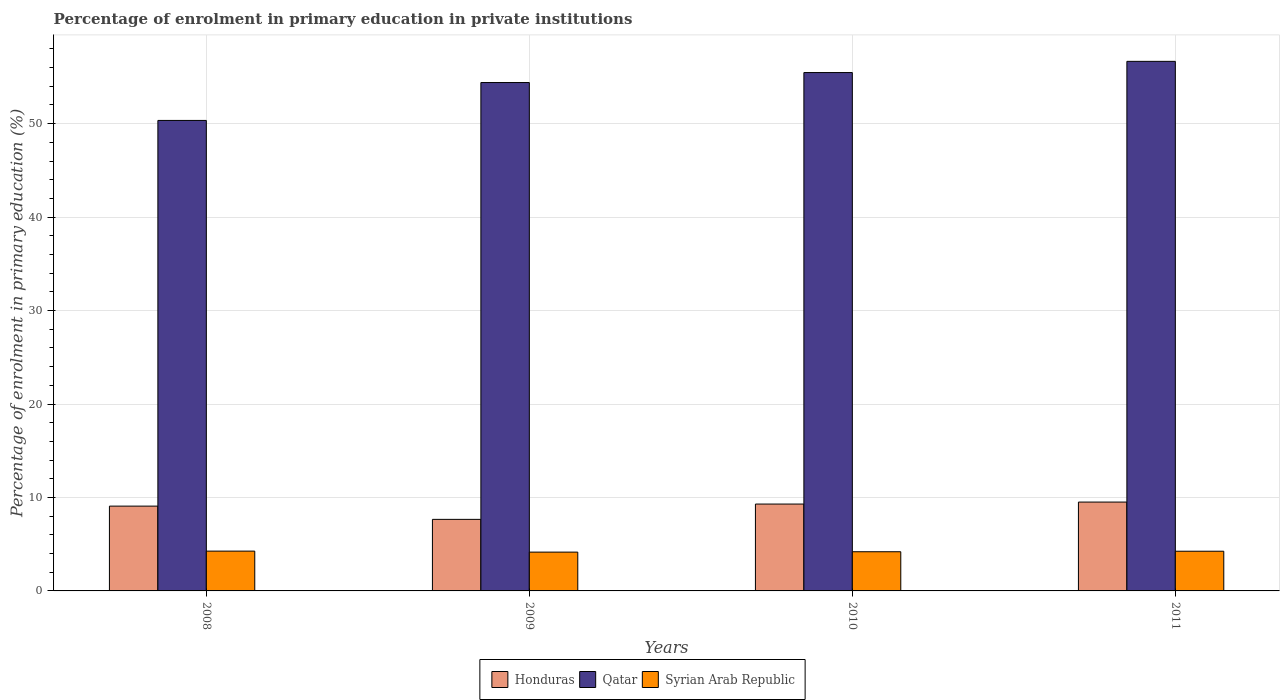How many different coloured bars are there?
Provide a succinct answer. 3. How many groups of bars are there?
Provide a succinct answer. 4. Are the number of bars per tick equal to the number of legend labels?
Offer a terse response. Yes. Are the number of bars on each tick of the X-axis equal?
Provide a succinct answer. Yes. How many bars are there on the 1st tick from the right?
Give a very brief answer. 3. What is the label of the 3rd group of bars from the left?
Offer a terse response. 2010. What is the percentage of enrolment in primary education in Syrian Arab Republic in 2008?
Keep it short and to the point. 4.26. Across all years, what is the maximum percentage of enrolment in primary education in Honduras?
Give a very brief answer. 9.51. Across all years, what is the minimum percentage of enrolment in primary education in Syrian Arab Republic?
Make the answer very short. 4.15. In which year was the percentage of enrolment in primary education in Qatar minimum?
Offer a very short reply. 2008. What is the total percentage of enrolment in primary education in Syrian Arab Republic in the graph?
Your answer should be compact. 16.85. What is the difference between the percentage of enrolment in primary education in Syrian Arab Republic in 2009 and that in 2010?
Your response must be concise. -0.04. What is the difference between the percentage of enrolment in primary education in Qatar in 2010 and the percentage of enrolment in primary education in Honduras in 2009?
Offer a terse response. 47.81. What is the average percentage of enrolment in primary education in Syrian Arab Republic per year?
Make the answer very short. 4.21. In the year 2008, what is the difference between the percentage of enrolment in primary education in Qatar and percentage of enrolment in primary education in Syrian Arab Republic?
Offer a terse response. 46.08. What is the ratio of the percentage of enrolment in primary education in Syrian Arab Republic in 2009 to that in 2010?
Your answer should be compact. 0.99. Is the percentage of enrolment in primary education in Qatar in 2008 less than that in 2010?
Give a very brief answer. Yes. What is the difference between the highest and the second highest percentage of enrolment in primary education in Qatar?
Keep it short and to the point. 1.2. What is the difference between the highest and the lowest percentage of enrolment in primary education in Honduras?
Your answer should be very brief. 1.85. Is the sum of the percentage of enrolment in primary education in Honduras in 2008 and 2010 greater than the maximum percentage of enrolment in primary education in Qatar across all years?
Ensure brevity in your answer.  No. What does the 3rd bar from the left in 2011 represents?
Offer a terse response. Syrian Arab Republic. What does the 1st bar from the right in 2008 represents?
Give a very brief answer. Syrian Arab Republic. Is it the case that in every year, the sum of the percentage of enrolment in primary education in Qatar and percentage of enrolment in primary education in Syrian Arab Republic is greater than the percentage of enrolment in primary education in Honduras?
Make the answer very short. Yes. Are all the bars in the graph horizontal?
Offer a terse response. No. How many years are there in the graph?
Your response must be concise. 4. How many legend labels are there?
Provide a short and direct response. 3. What is the title of the graph?
Give a very brief answer. Percentage of enrolment in primary education in private institutions. Does "Togo" appear as one of the legend labels in the graph?
Your answer should be compact. No. What is the label or title of the X-axis?
Offer a very short reply. Years. What is the label or title of the Y-axis?
Ensure brevity in your answer.  Percentage of enrolment in primary education (%). What is the Percentage of enrolment in primary education (%) in Honduras in 2008?
Your answer should be very brief. 9.07. What is the Percentage of enrolment in primary education (%) of Qatar in 2008?
Provide a short and direct response. 50.34. What is the Percentage of enrolment in primary education (%) of Syrian Arab Republic in 2008?
Provide a succinct answer. 4.26. What is the Percentage of enrolment in primary education (%) of Honduras in 2009?
Give a very brief answer. 7.66. What is the Percentage of enrolment in primary education (%) in Qatar in 2009?
Your answer should be very brief. 54.4. What is the Percentage of enrolment in primary education (%) in Syrian Arab Republic in 2009?
Offer a terse response. 4.15. What is the Percentage of enrolment in primary education (%) of Honduras in 2010?
Your answer should be compact. 9.3. What is the Percentage of enrolment in primary education (%) in Qatar in 2010?
Your answer should be compact. 55.47. What is the Percentage of enrolment in primary education (%) in Syrian Arab Republic in 2010?
Make the answer very short. 4.19. What is the Percentage of enrolment in primary education (%) in Honduras in 2011?
Give a very brief answer. 9.51. What is the Percentage of enrolment in primary education (%) of Qatar in 2011?
Offer a terse response. 56.67. What is the Percentage of enrolment in primary education (%) in Syrian Arab Republic in 2011?
Offer a terse response. 4.25. Across all years, what is the maximum Percentage of enrolment in primary education (%) of Honduras?
Offer a very short reply. 9.51. Across all years, what is the maximum Percentage of enrolment in primary education (%) in Qatar?
Provide a succinct answer. 56.67. Across all years, what is the maximum Percentage of enrolment in primary education (%) of Syrian Arab Republic?
Provide a succinct answer. 4.26. Across all years, what is the minimum Percentage of enrolment in primary education (%) in Honduras?
Provide a short and direct response. 7.66. Across all years, what is the minimum Percentage of enrolment in primary education (%) in Qatar?
Make the answer very short. 50.34. Across all years, what is the minimum Percentage of enrolment in primary education (%) in Syrian Arab Republic?
Ensure brevity in your answer.  4.15. What is the total Percentage of enrolment in primary education (%) in Honduras in the graph?
Provide a short and direct response. 35.53. What is the total Percentage of enrolment in primary education (%) of Qatar in the graph?
Offer a very short reply. 216.88. What is the total Percentage of enrolment in primary education (%) in Syrian Arab Republic in the graph?
Your answer should be compact. 16.85. What is the difference between the Percentage of enrolment in primary education (%) in Honduras in 2008 and that in 2009?
Offer a very short reply. 1.42. What is the difference between the Percentage of enrolment in primary education (%) in Qatar in 2008 and that in 2009?
Give a very brief answer. -4.06. What is the difference between the Percentage of enrolment in primary education (%) in Syrian Arab Republic in 2008 and that in 2009?
Make the answer very short. 0.11. What is the difference between the Percentage of enrolment in primary education (%) in Honduras in 2008 and that in 2010?
Your answer should be very brief. -0.22. What is the difference between the Percentage of enrolment in primary education (%) of Qatar in 2008 and that in 2010?
Your answer should be very brief. -5.12. What is the difference between the Percentage of enrolment in primary education (%) of Syrian Arab Republic in 2008 and that in 2010?
Offer a terse response. 0.07. What is the difference between the Percentage of enrolment in primary education (%) of Honduras in 2008 and that in 2011?
Provide a short and direct response. -0.43. What is the difference between the Percentage of enrolment in primary education (%) in Qatar in 2008 and that in 2011?
Provide a short and direct response. -6.32. What is the difference between the Percentage of enrolment in primary education (%) in Syrian Arab Republic in 2008 and that in 2011?
Provide a succinct answer. 0.01. What is the difference between the Percentage of enrolment in primary education (%) in Honduras in 2009 and that in 2010?
Your response must be concise. -1.64. What is the difference between the Percentage of enrolment in primary education (%) in Qatar in 2009 and that in 2010?
Your answer should be compact. -1.07. What is the difference between the Percentage of enrolment in primary education (%) in Syrian Arab Republic in 2009 and that in 2010?
Keep it short and to the point. -0.04. What is the difference between the Percentage of enrolment in primary education (%) of Honduras in 2009 and that in 2011?
Ensure brevity in your answer.  -1.85. What is the difference between the Percentage of enrolment in primary education (%) in Qatar in 2009 and that in 2011?
Your answer should be compact. -2.27. What is the difference between the Percentage of enrolment in primary education (%) of Syrian Arab Republic in 2009 and that in 2011?
Your response must be concise. -0.1. What is the difference between the Percentage of enrolment in primary education (%) in Honduras in 2010 and that in 2011?
Keep it short and to the point. -0.21. What is the difference between the Percentage of enrolment in primary education (%) in Qatar in 2010 and that in 2011?
Ensure brevity in your answer.  -1.2. What is the difference between the Percentage of enrolment in primary education (%) of Syrian Arab Republic in 2010 and that in 2011?
Offer a very short reply. -0.06. What is the difference between the Percentage of enrolment in primary education (%) in Honduras in 2008 and the Percentage of enrolment in primary education (%) in Qatar in 2009?
Give a very brief answer. -45.33. What is the difference between the Percentage of enrolment in primary education (%) of Honduras in 2008 and the Percentage of enrolment in primary education (%) of Syrian Arab Republic in 2009?
Your response must be concise. 4.92. What is the difference between the Percentage of enrolment in primary education (%) of Qatar in 2008 and the Percentage of enrolment in primary education (%) of Syrian Arab Republic in 2009?
Ensure brevity in your answer.  46.19. What is the difference between the Percentage of enrolment in primary education (%) of Honduras in 2008 and the Percentage of enrolment in primary education (%) of Qatar in 2010?
Your answer should be very brief. -46.39. What is the difference between the Percentage of enrolment in primary education (%) in Honduras in 2008 and the Percentage of enrolment in primary education (%) in Syrian Arab Republic in 2010?
Give a very brief answer. 4.88. What is the difference between the Percentage of enrolment in primary education (%) of Qatar in 2008 and the Percentage of enrolment in primary education (%) of Syrian Arab Republic in 2010?
Provide a short and direct response. 46.15. What is the difference between the Percentage of enrolment in primary education (%) in Honduras in 2008 and the Percentage of enrolment in primary education (%) in Qatar in 2011?
Your response must be concise. -47.59. What is the difference between the Percentage of enrolment in primary education (%) of Honduras in 2008 and the Percentage of enrolment in primary education (%) of Syrian Arab Republic in 2011?
Make the answer very short. 4.83. What is the difference between the Percentage of enrolment in primary education (%) of Qatar in 2008 and the Percentage of enrolment in primary education (%) of Syrian Arab Republic in 2011?
Your response must be concise. 46.1. What is the difference between the Percentage of enrolment in primary education (%) in Honduras in 2009 and the Percentage of enrolment in primary education (%) in Qatar in 2010?
Keep it short and to the point. -47.81. What is the difference between the Percentage of enrolment in primary education (%) of Honduras in 2009 and the Percentage of enrolment in primary education (%) of Syrian Arab Republic in 2010?
Keep it short and to the point. 3.47. What is the difference between the Percentage of enrolment in primary education (%) of Qatar in 2009 and the Percentage of enrolment in primary education (%) of Syrian Arab Republic in 2010?
Make the answer very short. 50.21. What is the difference between the Percentage of enrolment in primary education (%) in Honduras in 2009 and the Percentage of enrolment in primary education (%) in Qatar in 2011?
Ensure brevity in your answer.  -49.01. What is the difference between the Percentage of enrolment in primary education (%) in Honduras in 2009 and the Percentage of enrolment in primary education (%) in Syrian Arab Republic in 2011?
Offer a terse response. 3.41. What is the difference between the Percentage of enrolment in primary education (%) in Qatar in 2009 and the Percentage of enrolment in primary education (%) in Syrian Arab Republic in 2011?
Your answer should be compact. 50.15. What is the difference between the Percentage of enrolment in primary education (%) in Honduras in 2010 and the Percentage of enrolment in primary education (%) in Qatar in 2011?
Provide a succinct answer. -47.37. What is the difference between the Percentage of enrolment in primary education (%) of Honduras in 2010 and the Percentage of enrolment in primary education (%) of Syrian Arab Republic in 2011?
Offer a very short reply. 5.05. What is the difference between the Percentage of enrolment in primary education (%) of Qatar in 2010 and the Percentage of enrolment in primary education (%) of Syrian Arab Republic in 2011?
Provide a short and direct response. 51.22. What is the average Percentage of enrolment in primary education (%) in Honduras per year?
Make the answer very short. 8.88. What is the average Percentage of enrolment in primary education (%) of Qatar per year?
Provide a succinct answer. 54.22. What is the average Percentage of enrolment in primary education (%) of Syrian Arab Republic per year?
Your response must be concise. 4.21. In the year 2008, what is the difference between the Percentage of enrolment in primary education (%) of Honduras and Percentage of enrolment in primary education (%) of Qatar?
Your response must be concise. -41.27. In the year 2008, what is the difference between the Percentage of enrolment in primary education (%) in Honduras and Percentage of enrolment in primary education (%) in Syrian Arab Republic?
Make the answer very short. 4.81. In the year 2008, what is the difference between the Percentage of enrolment in primary education (%) in Qatar and Percentage of enrolment in primary education (%) in Syrian Arab Republic?
Your response must be concise. 46.08. In the year 2009, what is the difference between the Percentage of enrolment in primary education (%) in Honduras and Percentage of enrolment in primary education (%) in Qatar?
Offer a very short reply. -46.74. In the year 2009, what is the difference between the Percentage of enrolment in primary education (%) in Honduras and Percentage of enrolment in primary education (%) in Syrian Arab Republic?
Give a very brief answer. 3.5. In the year 2009, what is the difference between the Percentage of enrolment in primary education (%) in Qatar and Percentage of enrolment in primary education (%) in Syrian Arab Republic?
Your answer should be very brief. 50.25. In the year 2010, what is the difference between the Percentage of enrolment in primary education (%) of Honduras and Percentage of enrolment in primary education (%) of Qatar?
Make the answer very short. -46.17. In the year 2010, what is the difference between the Percentage of enrolment in primary education (%) of Honduras and Percentage of enrolment in primary education (%) of Syrian Arab Republic?
Your response must be concise. 5.1. In the year 2010, what is the difference between the Percentage of enrolment in primary education (%) of Qatar and Percentage of enrolment in primary education (%) of Syrian Arab Republic?
Provide a succinct answer. 51.28. In the year 2011, what is the difference between the Percentage of enrolment in primary education (%) of Honduras and Percentage of enrolment in primary education (%) of Qatar?
Give a very brief answer. -47.16. In the year 2011, what is the difference between the Percentage of enrolment in primary education (%) of Honduras and Percentage of enrolment in primary education (%) of Syrian Arab Republic?
Offer a very short reply. 5.26. In the year 2011, what is the difference between the Percentage of enrolment in primary education (%) in Qatar and Percentage of enrolment in primary education (%) in Syrian Arab Republic?
Offer a terse response. 52.42. What is the ratio of the Percentage of enrolment in primary education (%) of Honduras in 2008 to that in 2009?
Offer a very short reply. 1.19. What is the ratio of the Percentage of enrolment in primary education (%) of Qatar in 2008 to that in 2009?
Your answer should be compact. 0.93. What is the ratio of the Percentage of enrolment in primary education (%) in Syrian Arab Republic in 2008 to that in 2009?
Keep it short and to the point. 1.03. What is the ratio of the Percentage of enrolment in primary education (%) in Honduras in 2008 to that in 2010?
Make the answer very short. 0.98. What is the ratio of the Percentage of enrolment in primary education (%) in Qatar in 2008 to that in 2010?
Make the answer very short. 0.91. What is the ratio of the Percentage of enrolment in primary education (%) in Syrian Arab Republic in 2008 to that in 2010?
Keep it short and to the point. 1.02. What is the ratio of the Percentage of enrolment in primary education (%) of Honduras in 2008 to that in 2011?
Offer a very short reply. 0.95. What is the ratio of the Percentage of enrolment in primary education (%) of Qatar in 2008 to that in 2011?
Your answer should be very brief. 0.89. What is the ratio of the Percentage of enrolment in primary education (%) in Syrian Arab Republic in 2008 to that in 2011?
Give a very brief answer. 1. What is the ratio of the Percentage of enrolment in primary education (%) in Honduras in 2009 to that in 2010?
Offer a terse response. 0.82. What is the ratio of the Percentage of enrolment in primary education (%) in Qatar in 2009 to that in 2010?
Your response must be concise. 0.98. What is the ratio of the Percentage of enrolment in primary education (%) in Honduras in 2009 to that in 2011?
Give a very brief answer. 0.81. What is the ratio of the Percentage of enrolment in primary education (%) of Syrian Arab Republic in 2009 to that in 2011?
Your answer should be very brief. 0.98. What is the ratio of the Percentage of enrolment in primary education (%) of Honduras in 2010 to that in 2011?
Offer a terse response. 0.98. What is the ratio of the Percentage of enrolment in primary education (%) of Qatar in 2010 to that in 2011?
Make the answer very short. 0.98. What is the ratio of the Percentage of enrolment in primary education (%) of Syrian Arab Republic in 2010 to that in 2011?
Your response must be concise. 0.99. What is the difference between the highest and the second highest Percentage of enrolment in primary education (%) in Honduras?
Your response must be concise. 0.21. What is the difference between the highest and the second highest Percentage of enrolment in primary education (%) of Qatar?
Your answer should be compact. 1.2. What is the difference between the highest and the second highest Percentage of enrolment in primary education (%) in Syrian Arab Republic?
Offer a very short reply. 0.01. What is the difference between the highest and the lowest Percentage of enrolment in primary education (%) of Honduras?
Ensure brevity in your answer.  1.85. What is the difference between the highest and the lowest Percentage of enrolment in primary education (%) of Qatar?
Offer a terse response. 6.32. What is the difference between the highest and the lowest Percentage of enrolment in primary education (%) in Syrian Arab Republic?
Your answer should be very brief. 0.11. 